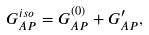<formula> <loc_0><loc_0><loc_500><loc_500>G _ { A P } ^ { i s o } = G _ { A P } ^ { ( 0 ) } + G ^ { \prime } _ { A P } ,</formula> 